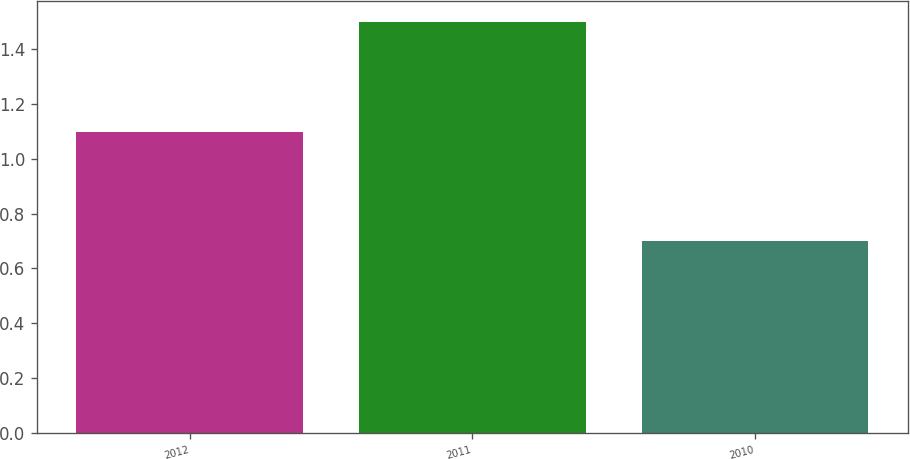Convert chart to OTSL. <chart><loc_0><loc_0><loc_500><loc_500><bar_chart><fcel>2012<fcel>2011<fcel>2010<nl><fcel>1.1<fcel>1.5<fcel>0.7<nl></chart> 